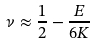<formula> <loc_0><loc_0><loc_500><loc_500>\nu \approx \frac { 1 } { 2 } - \frac { E } { 6 K }</formula> 